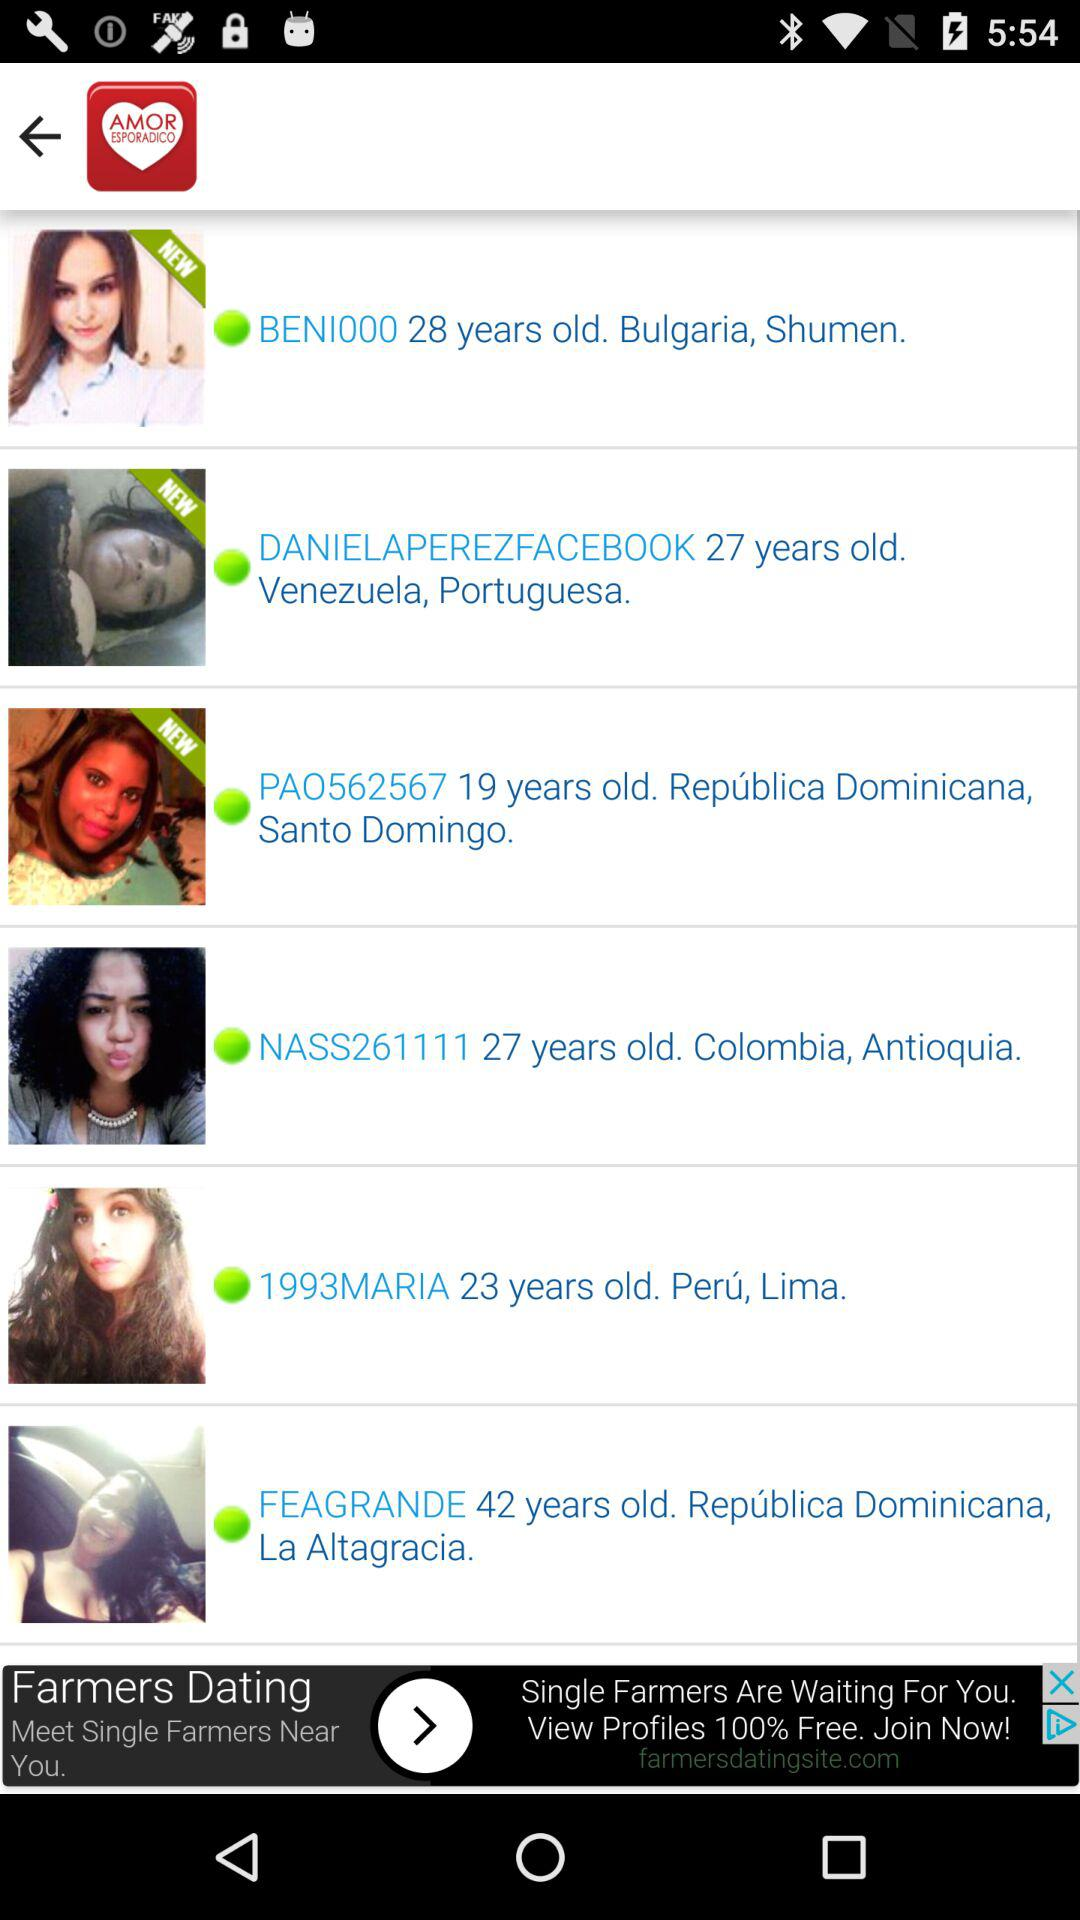Where is "NASS261111" from? "NASS261111" is from Colombia, Antioquia. 